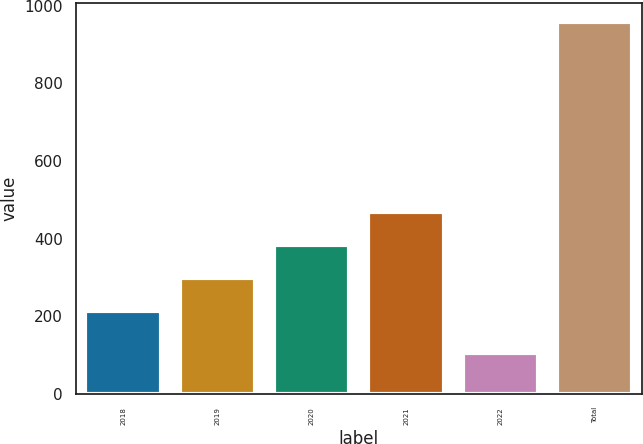<chart> <loc_0><loc_0><loc_500><loc_500><bar_chart><fcel>2018<fcel>2019<fcel>2020<fcel>2021<fcel>2022<fcel>Total<nl><fcel>213<fcel>298.2<fcel>383.4<fcel>468.6<fcel>106<fcel>958<nl></chart> 